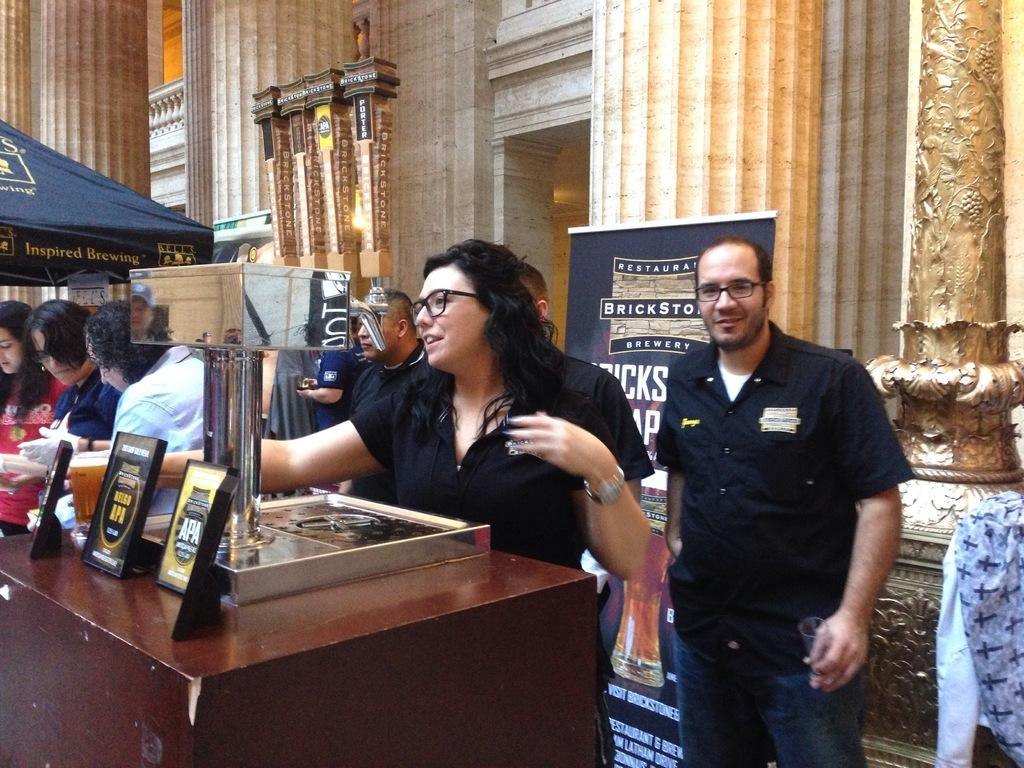What is happening in the image? There are people standing in the image. What can be seen in the background of the image? There is a hoarding visible in the image. Where is the goat leading the people in the image? There is no goat present in the image, so it cannot be leading anyone. 